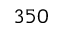Convert formula to latex. <formula><loc_0><loc_0><loc_500><loc_500>3 5 0</formula> 